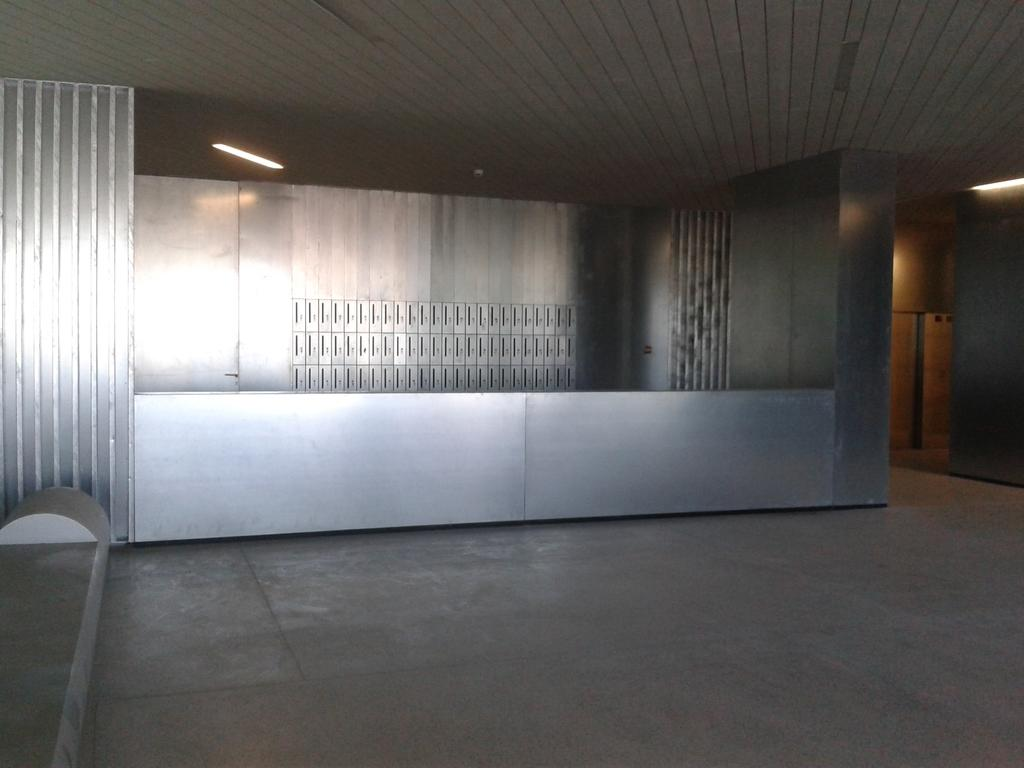What part of a building is shown in the image? The image shows the inner part of a building. What type of object can be seen in the image? There is a steel object in the image. What can be seen in the background of the image? There are lights visible in the background of the image. How does the brick contribute to the soda's taste in the image? There is no brick or soda present in the image, so it is not possible to determine any contribution to the soda's taste. 